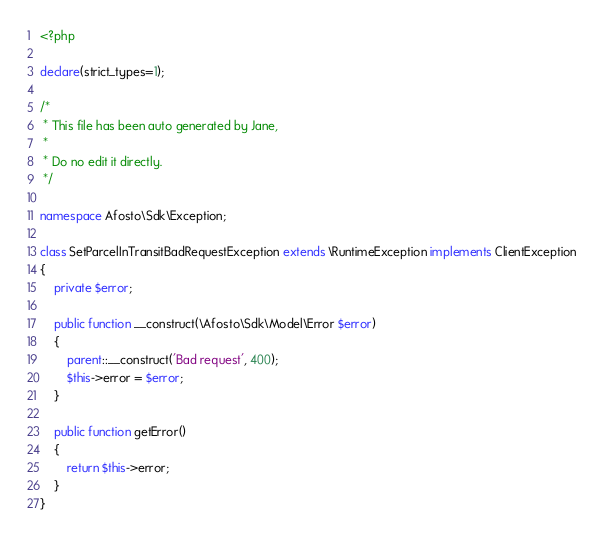<code> <loc_0><loc_0><loc_500><loc_500><_PHP_><?php

declare(strict_types=1);

/*
 * This file has been auto generated by Jane,
 *
 * Do no edit it directly.
 */

namespace Afosto\Sdk\Exception;

class SetParcelInTransitBadRequestException extends \RuntimeException implements ClientException
{
    private $error;

    public function __construct(\Afosto\Sdk\Model\Error $error)
    {
        parent::__construct('Bad request', 400);
        $this->error = $error;
    }

    public function getError()
    {
        return $this->error;
    }
}
</code> 